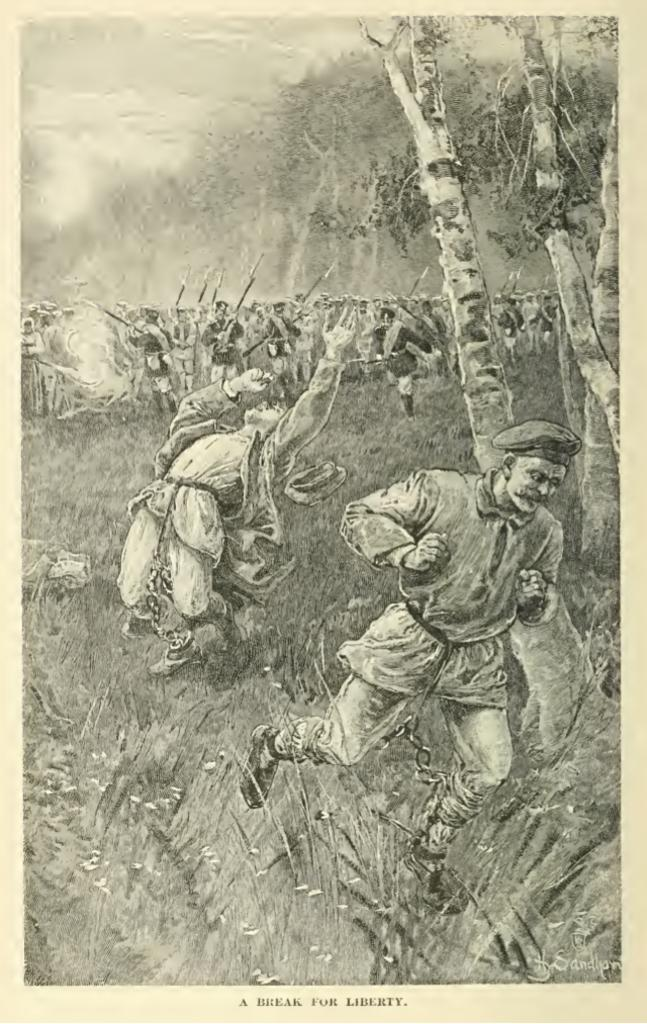What is depicted on the paper in the image? There is an image on the paper, which contains a group of people standing. What type of natural environment is shown in the image? The image includes grass, plants, trees, and the sky, suggesting a natural setting. What else can be found on the paper besides the image? There are words on the paper. How many deer can be seen grazing in the grass in the image? There are no deer present in the image; it features a group of people standing in a natural environment with grass, plants, trees, and the sky. 